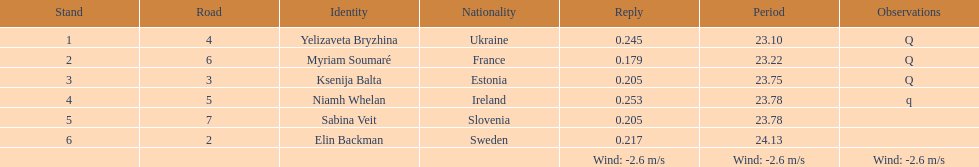The first person to finish in heat 1? Yelizaveta Bryzhina. Would you mind parsing the complete table? {'header': ['Stand', 'Road', 'Identity', 'Nationality', 'Reply', 'Period', 'Observations'], 'rows': [['1', '4', 'Yelizaveta Bryzhina', 'Ukraine', '0.245', '23.10', 'Q'], ['2', '6', 'Myriam Soumaré', 'France', '0.179', '23.22', 'Q'], ['3', '3', 'Ksenija Balta', 'Estonia', '0.205', '23.75', 'Q'], ['4', '5', 'Niamh Whelan', 'Ireland', '0.253', '23.78', 'q'], ['5', '7', 'Sabina Veit', 'Slovenia', '0.205', '23.78', ''], ['6', '2', 'Elin Backman', 'Sweden', '0.217', '24.13', ''], ['', '', '', '', 'Wind: -2.6\xa0m/s', 'Wind: -2.6\xa0m/s', 'Wind: -2.6\xa0m/s']]} 